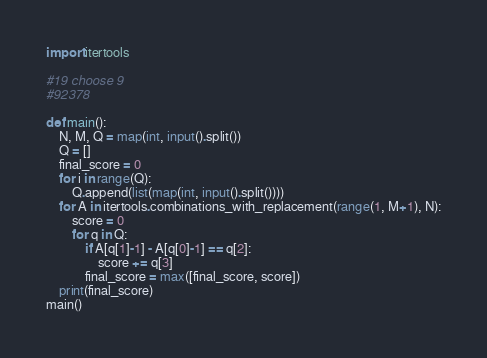Convert code to text. <code><loc_0><loc_0><loc_500><loc_500><_Python_>import itertools

#19 choose 9
#92378

def main():
    N, M, Q = map(int, input().split())
    Q = []
    final_score = 0
    for i in range(Q):
        Q.append(list(map(int, input().split())))
    for A in itertools.combinations_with_replacement(range(1, M+1), N):
        score = 0
        for q in Q:
            if A[q[1]-1] - A[q[0]-1] == q[2]:
                score += q[3]
            final_score = max([final_score, score])
    print(final_score)
main()</code> 